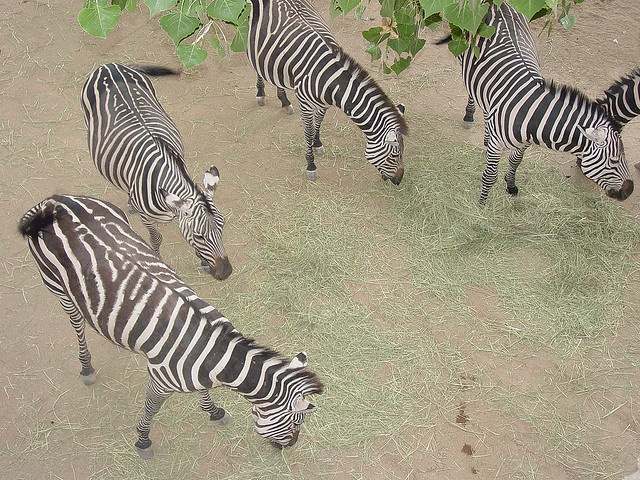Describe the objects in this image and their specific colors. I can see zebra in tan, gray, lightgray, darkgray, and black tones, zebra in tan, gray, darkgray, lightgray, and black tones, zebra in tan, black, gray, lightgray, and darkgray tones, zebra in tan, gray, black, lightgray, and darkgray tones, and zebra in tan, black, darkgray, and gray tones in this image. 